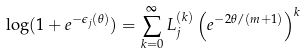<formula> <loc_0><loc_0><loc_500><loc_500>\log ( 1 + e ^ { - \epsilon _ { j } ( \theta ) } ) = \sum _ { k = 0 } ^ { \infty } L _ { j } ^ { ( k ) } \left ( e ^ { - 2 \theta / ( m + 1 ) } \right ) ^ { k }</formula> 